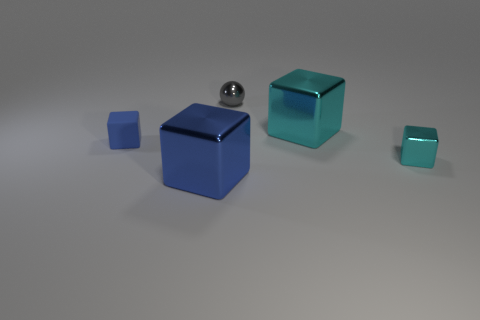Subtract all small cyan shiny blocks. How many blocks are left? 3 Add 2 small blue rubber cubes. How many objects exist? 7 Subtract all purple blocks. Subtract all gray spheres. How many blocks are left? 4 Subtract all blocks. How many objects are left? 1 Subtract all small blue things. Subtract all gray metal things. How many objects are left? 3 Add 1 gray metal things. How many gray metal things are left? 2 Add 1 large gray metal blocks. How many large gray metal blocks exist? 1 Subtract 1 gray spheres. How many objects are left? 4 